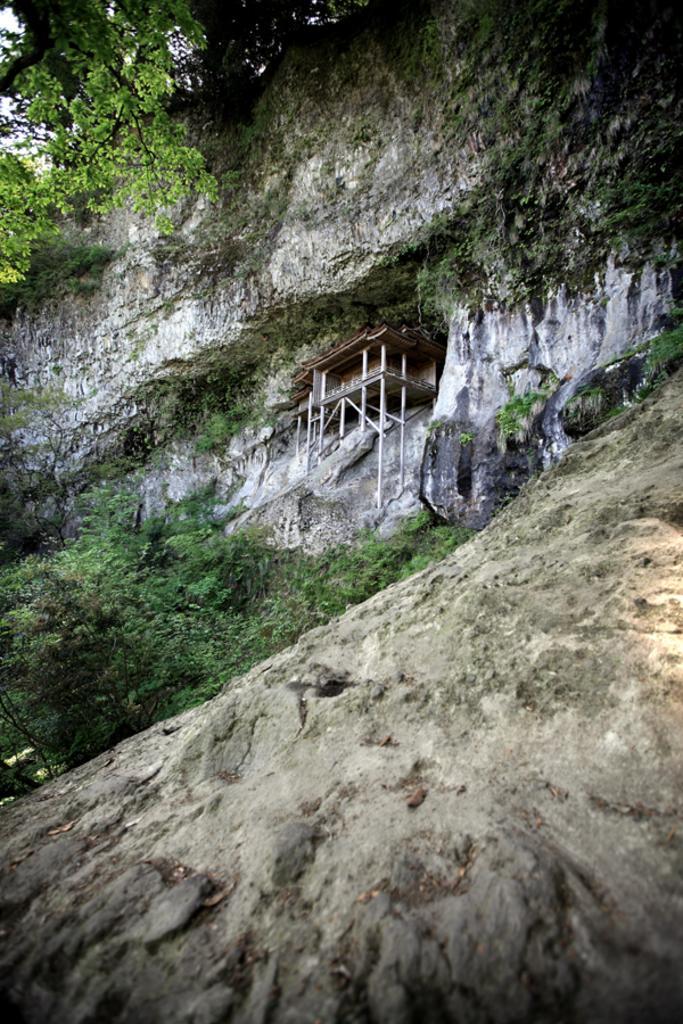In one or two sentences, can you explain what this image depicts? In this image I can see number of trees and in the center of the image I can see a house on the rock. 